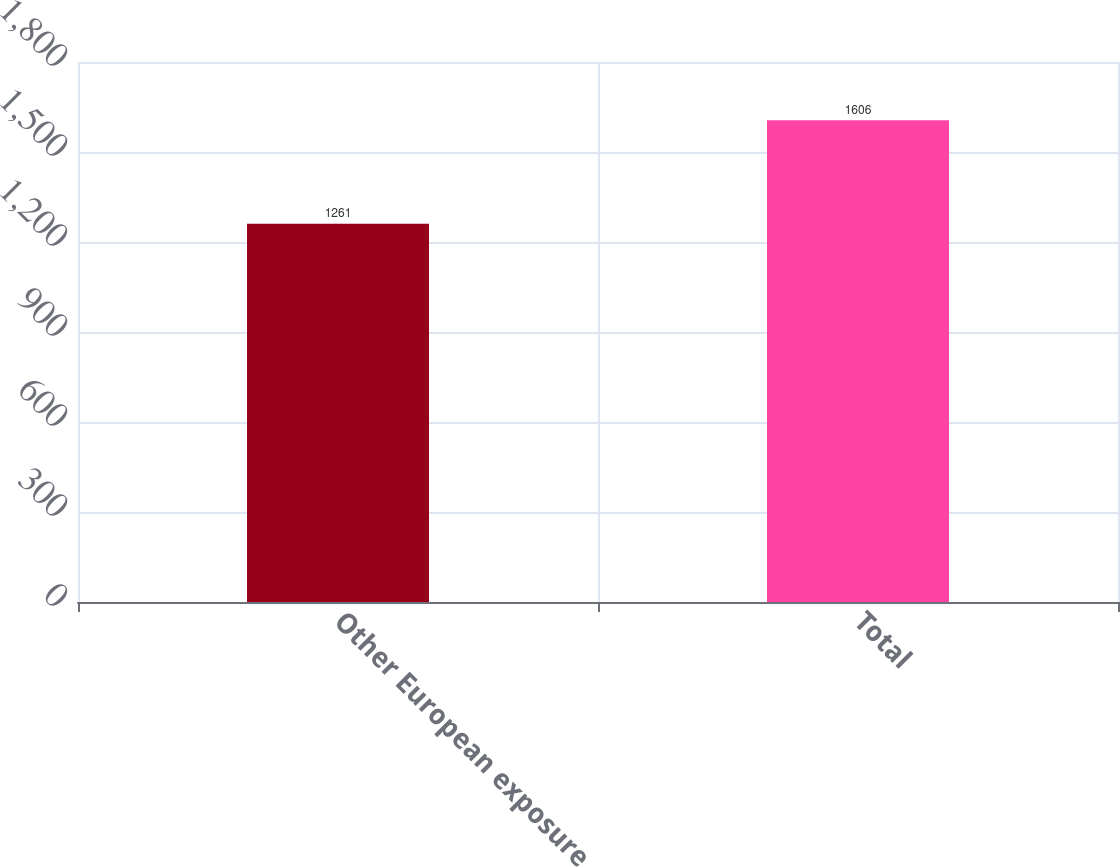<chart> <loc_0><loc_0><loc_500><loc_500><bar_chart><fcel>Other European exposure<fcel>Total<nl><fcel>1261<fcel>1606<nl></chart> 